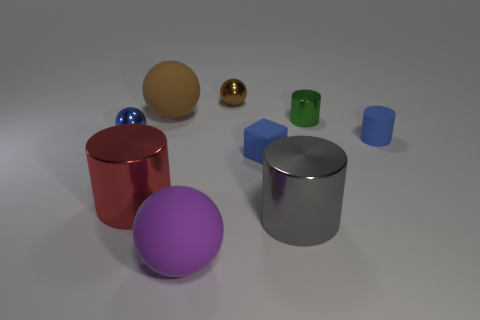What kind of lighting is affecting the objects, and are there any shadows? The objects are illuminated by what appears to be a white, diffuse overhead light, casting soft shadows on the ground to the right of the objects. The lighting suggests an indoor setting, possibly with artificial lighting, as the shadows have soft edges and are not very dark. 